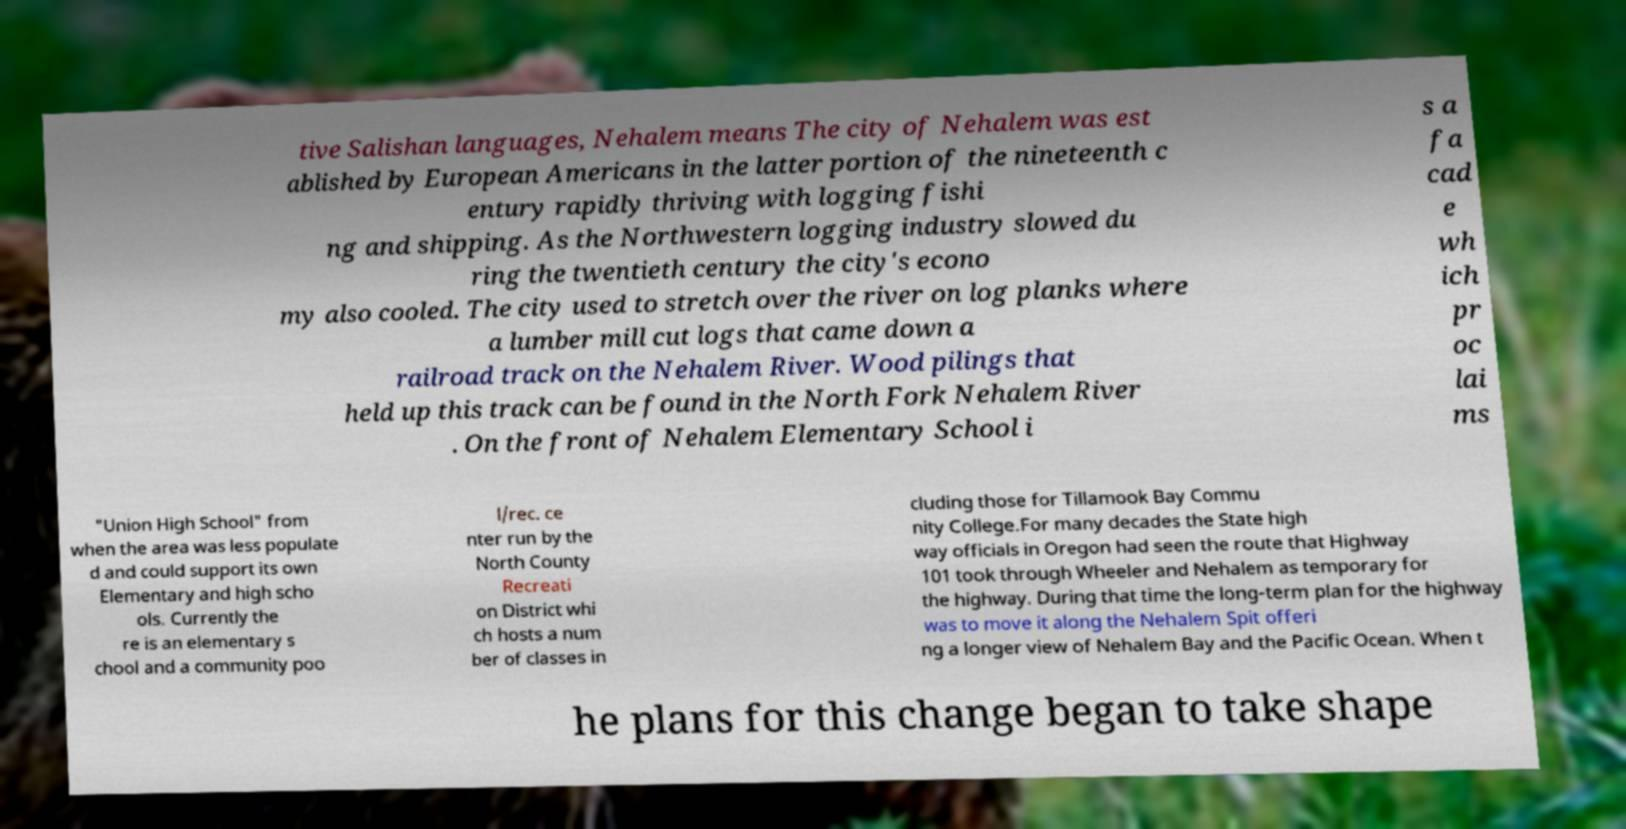For documentation purposes, I need the text within this image transcribed. Could you provide that? tive Salishan languages, Nehalem means The city of Nehalem was est ablished by European Americans in the latter portion of the nineteenth c entury rapidly thriving with logging fishi ng and shipping. As the Northwestern logging industry slowed du ring the twentieth century the city's econo my also cooled. The city used to stretch over the river on log planks where a lumber mill cut logs that came down a railroad track on the Nehalem River. Wood pilings that held up this track can be found in the North Fork Nehalem River . On the front of Nehalem Elementary School i s a fa cad e wh ich pr oc lai ms "Union High School" from when the area was less populate d and could support its own Elementary and high scho ols. Currently the re is an elementary s chool and a community poo l/rec. ce nter run by the North County Recreati on District whi ch hosts a num ber of classes in cluding those for Tillamook Bay Commu nity College.For many decades the State high way officials in Oregon had seen the route that Highway 101 took through Wheeler and Nehalem as temporary for the highway. During that time the long-term plan for the highway was to move it along the Nehalem Spit offeri ng a longer view of Nehalem Bay and the Pacific Ocean. When t he plans for this change began to take shape 